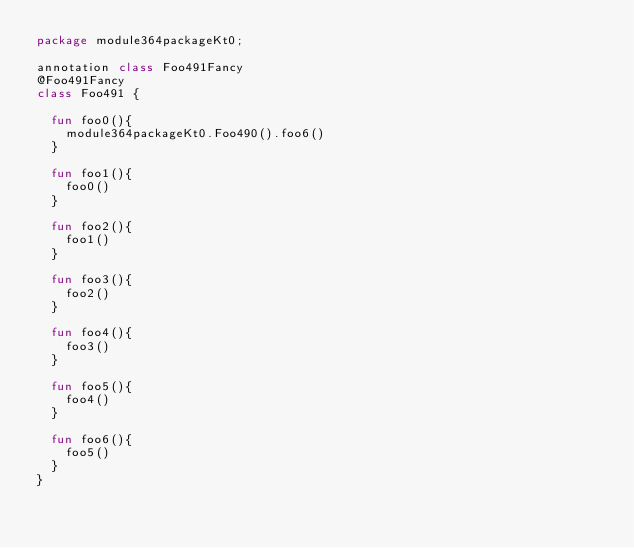<code> <loc_0><loc_0><loc_500><loc_500><_Kotlin_>package module364packageKt0;

annotation class Foo491Fancy
@Foo491Fancy
class Foo491 {

  fun foo0(){
    module364packageKt0.Foo490().foo6()
  }

  fun foo1(){
    foo0()
  }

  fun foo2(){
    foo1()
  }

  fun foo3(){
    foo2()
  }

  fun foo4(){
    foo3()
  }

  fun foo5(){
    foo4()
  }

  fun foo6(){
    foo5()
  }
}</code> 